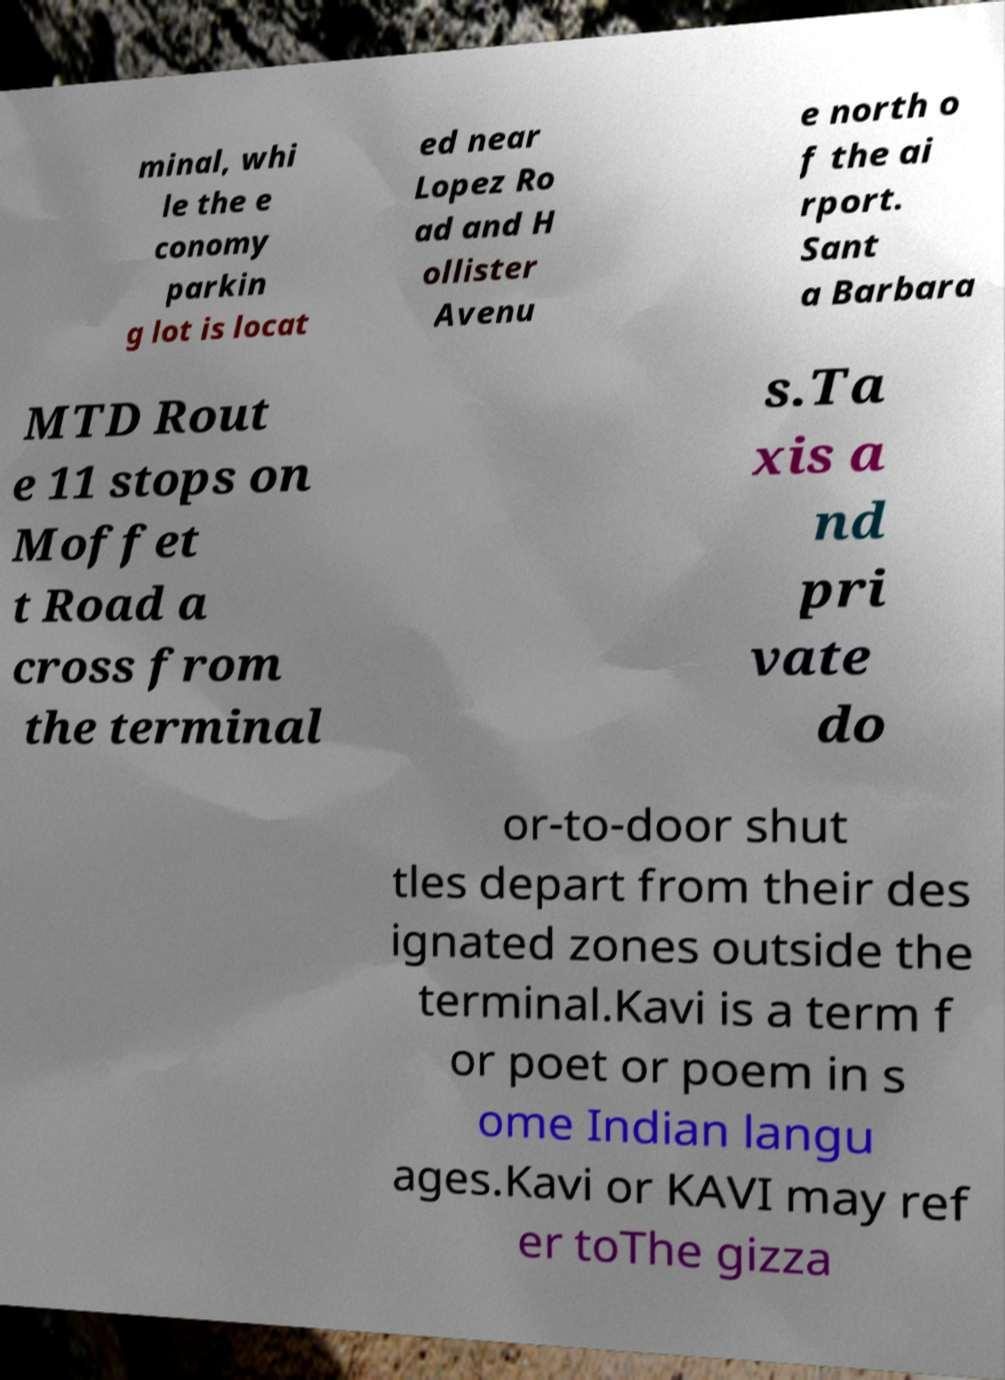Could you assist in decoding the text presented in this image and type it out clearly? minal, whi le the e conomy parkin g lot is locat ed near Lopez Ro ad and H ollister Avenu e north o f the ai rport. Sant a Barbara MTD Rout e 11 stops on Moffet t Road a cross from the terminal s.Ta xis a nd pri vate do or-to-door shut tles depart from their des ignated zones outside the terminal.Kavi is a term f or poet or poem in s ome Indian langu ages.Kavi or KAVI may ref er toThe gizza 